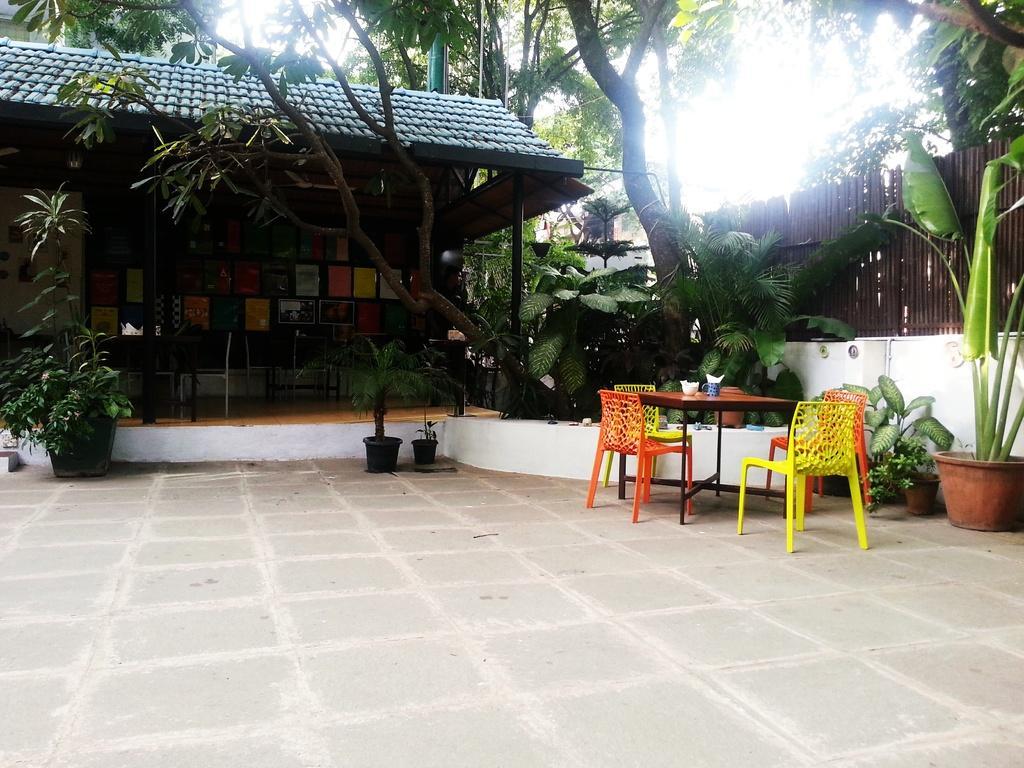Can you describe this image briefly? As we can see in the image there is a house, trees, plants, pots, skye, table and chairs. On table there is a glass and a bowl. 